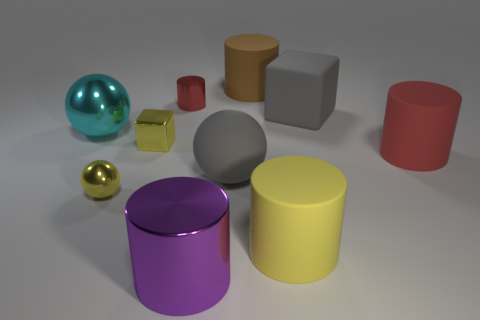There is a metal cylinder that is in front of the yellow sphere; what color is it?
Provide a short and direct response. Purple. The red object that is the same material as the brown thing is what size?
Provide a short and direct response. Large. What number of metallic balls are to the right of the large metal thing behind the large red object?
Offer a very short reply. 1. What number of big purple shiny objects are in front of the big purple shiny cylinder?
Your answer should be compact. 0. What color is the big shiny object that is in front of the cube in front of the block that is right of the brown cylinder?
Make the answer very short. Purple. There is a cylinder that is to the right of the matte cube; does it have the same color as the metal cylinder that is behind the big yellow thing?
Make the answer very short. Yes. The large thing that is to the left of the tiny yellow shiny thing that is on the right side of the yellow sphere is what shape?
Provide a short and direct response. Sphere. Is there a purple thing of the same size as the brown cylinder?
Offer a very short reply. Yes. How many other large metallic objects are the same shape as the cyan metallic thing?
Provide a succinct answer. 0. Is the number of big yellow cylinders behind the large brown cylinder the same as the number of big cyan spheres that are right of the big matte sphere?
Provide a succinct answer. Yes. 